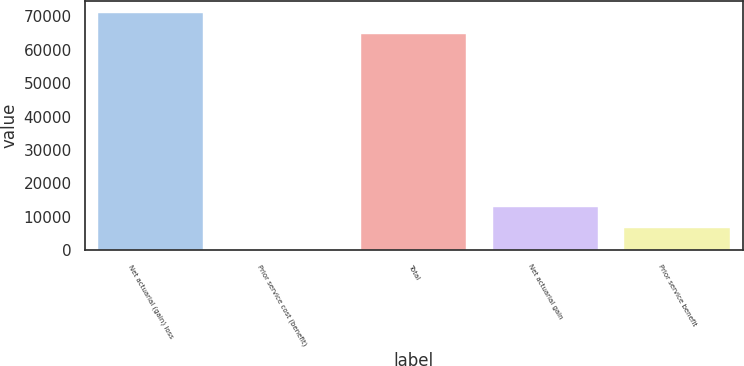Convert chart to OTSL. <chart><loc_0><loc_0><loc_500><loc_500><bar_chart><fcel>Net actuarial (gain) loss<fcel>Prior service cost (benefit)<fcel>Total<fcel>Net actuarial gain<fcel>Prior service benefit<nl><fcel>71161.2<fcel>117<fcel>64692<fcel>13055.4<fcel>6586.2<nl></chart> 